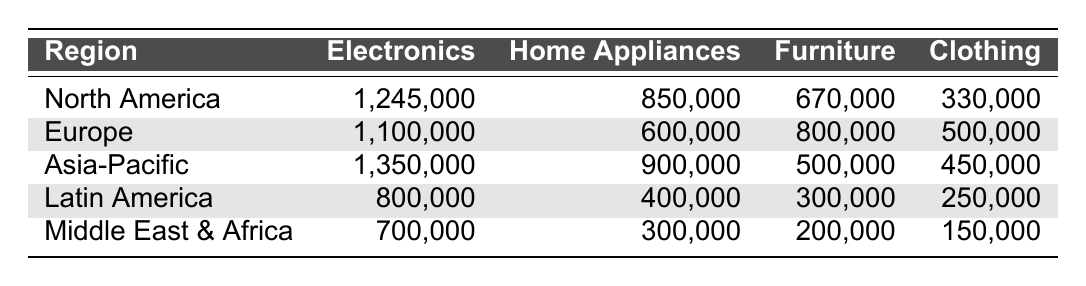What is the total sales for Electronics in North America? North America has sales of 1,245,000 for Electronics, which is directly stated in the table.
Answer: 1,245,000 Which region has the highest sales in Home Appliances? The sales for Home Appliances are 850,000 in North America, 600,000 in Europe, 900,000 in Asia-Pacific, 400,000 in Latin America, and 300,000 in the Middle East & Africa. The maximum value is 900,000 in Asia-Pacific.
Answer: Asia-Pacific What is the total sales for Furniture across all regions? The total sales for Furniture are calculated by summing up the values: 670,000 (North America) + 800,000 (Europe) + 500,000 (Asia-Pacific) + 300,000 (Latin America) + 200,000 (Middle East & Africa) = 2,470,000.
Answer: 2,470,000 Is the Electronics sales in Latin America higher than in Middle East & Africa? The Electronics sales in Latin America are 800,000, while in Middle East & Africa it's 700,000. Therefore, 800,000 > 700,000, which confirms the statement is true.
Answer: Yes What is the average sales figure for Clothing across all regions? The sales for Clothing are 330,000 (North America), 500,000 (Europe), 450,000 (Asia-Pacific), 250,000 (Latin America), and 150,000 (Middle East & Africa). Adding these gives 1,680,000, and dividing by the number of regions (5) gives an average of 336,000.
Answer: 336,000 Which product category has the lowest total sales? The total sales for each product category are compared: 1245000 + 1100000 + 1350000 + 800000 + 700000 for Electronics (total: 7,250,000), 850000 + 600000 + 900000 + 400000 + 300000 for Home Appliances (total: 3,050,000), 670000 + 800000 + 500000 + 300000 + 200000 for Furniture (total: 2,470,000), and 330000 + 500000 + 450000 + 250000 + 150000 for Clothing (total: 1,680,000). The category with the lowest total is Clothing.
Answer: Clothing What is the difference in sales between Electronics and Home Appliances in the Asia-Pacific region? The sales for Electronics in Asia-Pacific are 1,350,000, and for Home Appliances, it is 900,000. The difference is 1,350,000 - 900,000 = 450,000.
Answer: 450,000 Which region has a higher total sales for all product categories: Europe or North America? Calculating total sales: North America has 1,245,000 + 850,000 + 670,000 + 330,000 = 3,095,000 and Europe has 1,100,000 + 600,000 + 800,000 + 500,000 = 3,000,000. North America is greater than Europe.
Answer: North America What percentage of total sales for Clothing does Europe represent? First, total Clothing sales across all regions is 1,680,000. Europe’s Clothing sales are 500,000. The percentage calculation is (500,000 / 1,680,000) * 100, which equals approximately 29.76%.
Answer: 29.76% Which product category generates the highest sales overall? Total sales for each category are calculated: Electronics = 7,250,000, Home Appliances = 3,050,000, Furniture = 2,470,000, Clothing = 1,680,000. The highest sales category is Electronics.
Answer: Electronics 